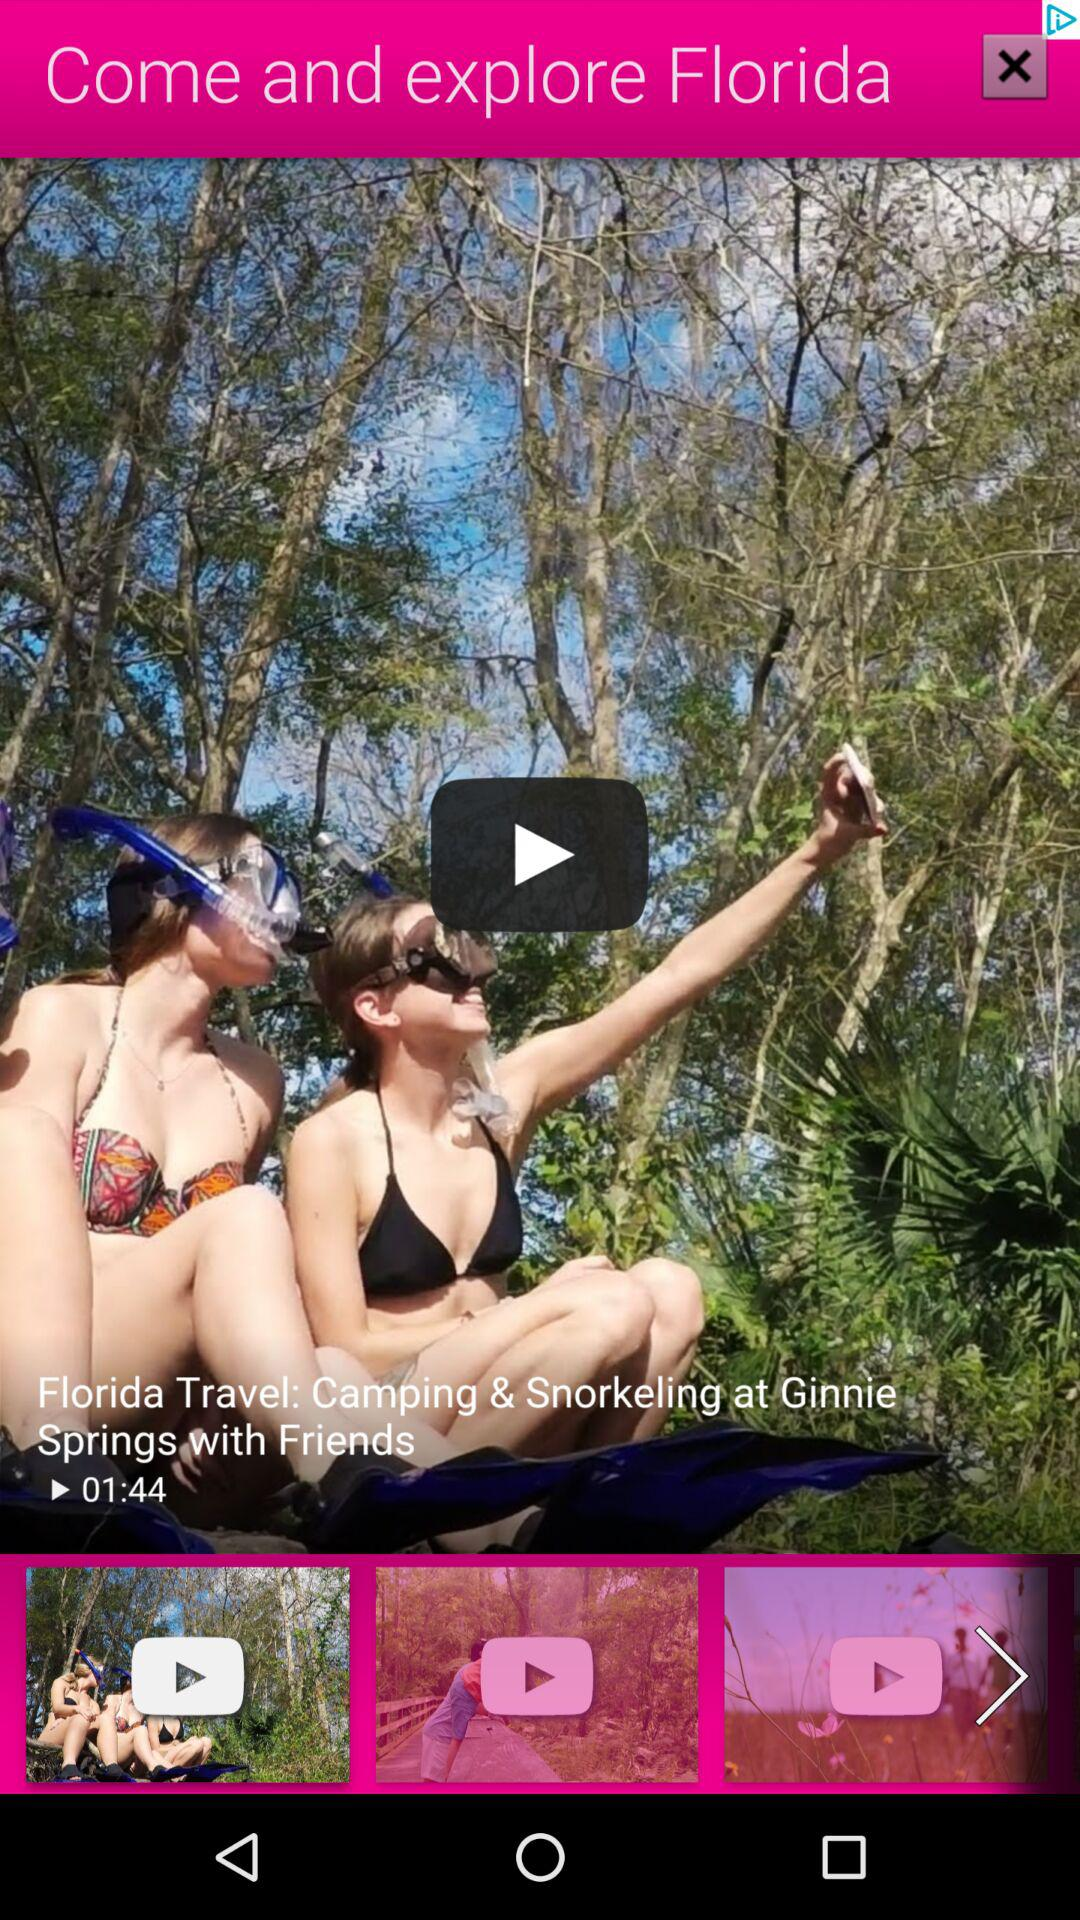What is the duration of the video? The duration of the video is 1 minute and 44 seconds. 